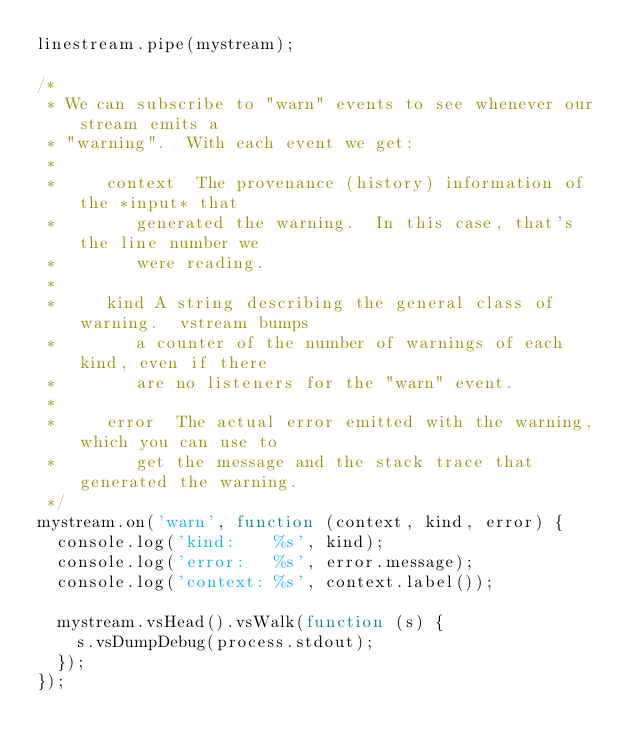Convert code to text. <code><loc_0><loc_0><loc_500><loc_500><_JavaScript_>linestream.pipe(mystream);

/*
 * We can subscribe to "warn" events to see whenever our stream emits a
 * "warning".  With each event we get:
 *
 *     context  The provenance (history) information of the *input* that
 *     		generated the warning.  In this case, that's the line number we
 *     		were reading.
 *
 *     kind	A string describing the general class of warning.  vstream bumps
 *     		a counter of the number of warnings of each kind, even if there
 *     		are no listeners for the "warn" event.
 *
 *     error	The actual error emitted with the warning, which you can use to
 *     		get the message and the stack trace that generated the warning.
 */
mystream.on('warn', function (context, kind, error) {
	console.log('kind:    %s', kind);
	console.log('error:   %s', error.message);
	console.log('context: %s', context.label());

	mystream.vsHead().vsWalk(function (s) {
		s.vsDumpDebug(process.stdout);
	});
});
</code> 